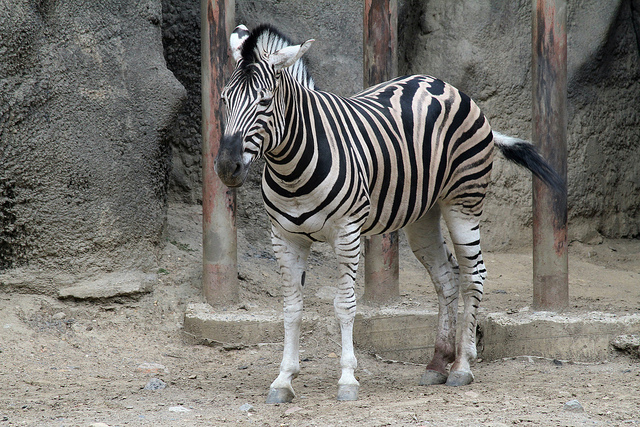What species of zebra is this? The zebra shown appears to be a Plains zebra, identified by its wide stripes that fade into the belly and distinct facial patterns. 